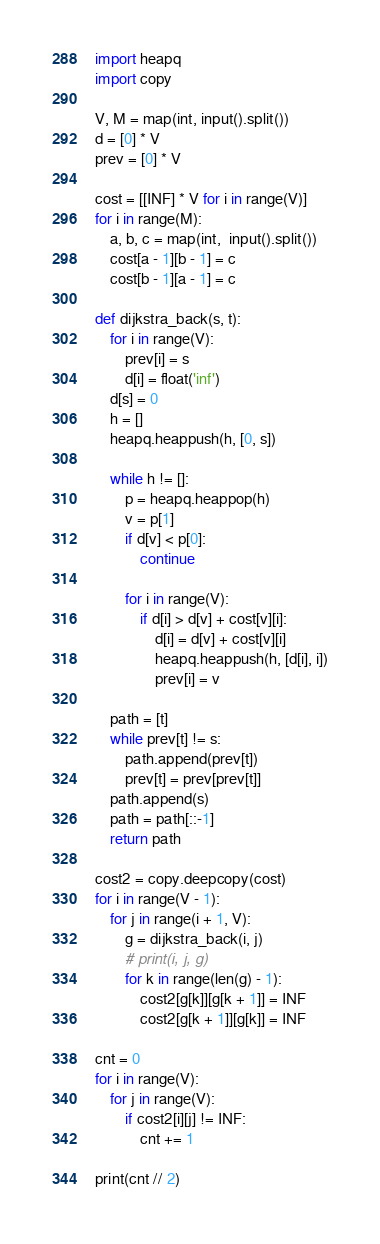<code> <loc_0><loc_0><loc_500><loc_500><_Python_>import heapq
import copy

V, M = map(int, input().split())
d = [0] * V
prev = [0] * V

cost = [[INF] * V for i in range(V)]
for i in range(M):
    a, b, c = map(int,  input().split())
    cost[a - 1][b - 1] = c
    cost[b - 1][a - 1] = c
    
def dijkstra_back(s, t):
    for i in range(V):
        prev[i] = s
        d[i] = float('inf')
    d[s] = 0
    h = []
    heapq.heappush(h, [0, s])
    
    while h != []:
        p = heapq.heappop(h)
        v = p[1]
        if d[v] < p[0]:
            continue
         
        for i in range(V):
            if d[i] > d[v] + cost[v][i]: 
                d[i] = d[v] + cost[v][i]
                heapq.heappush(h, [d[i], i])
                prev[i] = v
        
    path = [t]
    while prev[t] != s:
        path.append(prev[t])
        prev[t] = prev[prev[t]]
    path.append(s)
    path = path[::-1]
    return path

cost2 = copy.deepcopy(cost)
for i in range(V - 1):
    for j in range(i + 1, V):
        g = dijkstra_back(i, j)
        # print(i, j, g)
        for k in range(len(g) - 1):
            cost2[g[k]][g[k + 1]] = INF
            cost2[g[k + 1]][g[k]] = INF
            
cnt = 0
for i in range(V):
    for j in range(V):
        if cost2[i][j] != INF:
            cnt += 1
                     
print(cnt // 2)</code> 